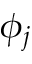<formula> <loc_0><loc_0><loc_500><loc_500>\phi _ { j }</formula> 